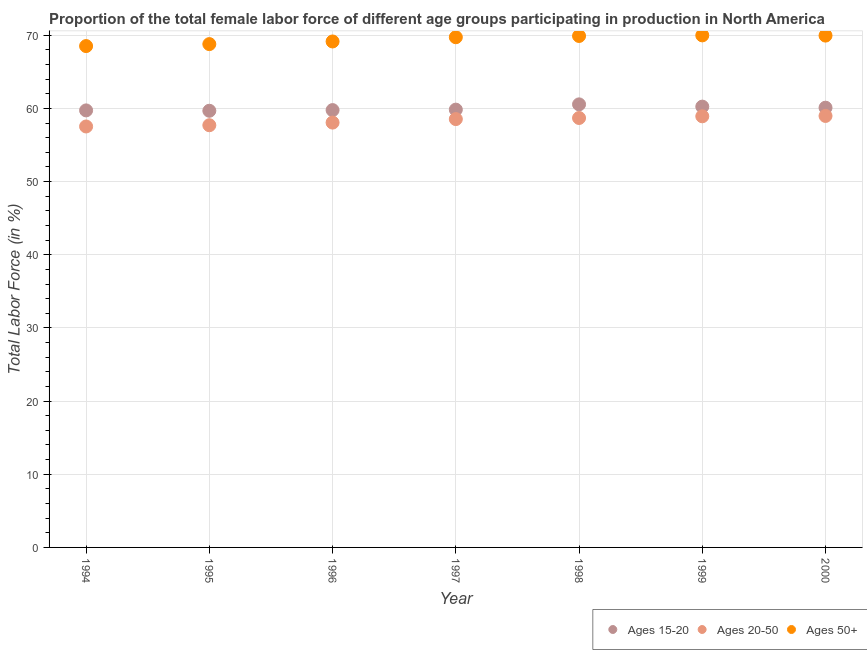How many different coloured dotlines are there?
Give a very brief answer. 3. What is the percentage of female labor force above age 50 in 1994?
Your answer should be compact. 68.52. Across all years, what is the maximum percentage of female labor force within the age group 15-20?
Make the answer very short. 60.55. Across all years, what is the minimum percentage of female labor force above age 50?
Offer a very short reply. 68.52. What is the total percentage of female labor force within the age group 20-50 in the graph?
Keep it short and to the point. 408.41. What is the difference between the percentage of female labor force above age 50 in 1995 and that in 1996?
Your answer should be compact. -0.36. What is the difference between the percentage of female labor force within the age group 20-50 in 1997 and the percentage of female labor force above age 50 in 1996?
Keep it short and to the point. -10.61. What is the average percentage of female labor force within the age group 15-20 per year?
Offer a very short reply. 59.99. In the year 1996, what is the difference between the percentage of female labor force above age 50 and percentage of female labor force within the age group 15-20?
Provide a short and direct response. 9.38. In how many years, is the percentage of female labor force within the age group 20-50 greater than 54 %?
Give a very brief answer. 7. What is the ratio of the percentage of female labor force within the age group 20-50 in 1998 to that in 1999?
Your response must be concise. 1. What is the difference between the highest and the second highest percentage of female labor force within the age group 15-20?
Make the answer very short. 0.31. What is the difference between the highest and the lowest percentage of female labor force above age 50?
Give a very brief answer. 1.46. Is the sum of the percentage of female labor force within the age group 15-20 in 1995 and 1997 greater than the maximum percentage of female labor force within the age group 20-50 across all years?
Provide a succinct answer. Yes. How many years are there in the graph?
Offer a terse response. 7. Are the values on the major ticks of Y-axis written in scientific E-notation?
Provide a short and direct response. No. Does the graph contain grids?
Offer a terse response. Yes. Where does the legend appear in the graph?
Keep it short and to the point. Bottom right. How are the legend labels stacked?
Provide a succinct answer. Horizontal. What is the title of the graph?
Provide a succinct answer. Proportion of the total female labor force of different age groups participating in production in North America. What is the label or title of the Y-axis?
Ensure brevity in your answer.  Total Labor Force (in %). What is the Total Labor Force (in %) of Ages 15-20 in 1994?
Provide a succinct answer. 59.73. What is the Total Labor Force (in %) of Ages 20-50 in 1994?
Keep it short and to the point. 57.53. What is the Total Labor Force (in %) in Ages 50+ in 1994?
Offer a very short reply. 68.52. What is the Total Labor Force (in %) in Ages 15-20 in 1995?
Provide a short and direct response. 59.68. What is the Total Labor Force (in %) of Ages 20-50 in 1995?
Offer a terse response. 57.7. What is the Total Labor Force (in %) of Ages 50+ in 1995?
Your response must be concise. 68.79. What is the Total Labor Force (in %) of Ages 15-20 in 1996?
Provide a succinct answer. 59.77. What is the Total Labor Force (in %) in Ages 20-50 in 1996?
Your answer should be compact. 58.06. What is the Total Labor Force (in %) in Ages 50+ in 1996?
Your answer should be very brief. 69.15. What is the Total Labor Force (in %) in Ages 15-20 in 1997?
Offer a very short reply. 59.83. What is the Total Labor Force (in %) of Ages 20-50 in 1997?
Your answer should be compact. 58.54. What is the Total Labor Force (in %) of Ages 50+ in 1997?
Your answer should be compact. 69.73. What is the Total Labor Force (in %) in Ages 15-20 in 1998?
Keep it short and to the point. 60.55. What is the Total Labor Force (in %) in Ages 20-50 in 1998?
Provide a succinct answer. 58.69. What is the Total Labor Force (in %) of Ages 50+ in 1998?
Make the answer very short. 69.9. What is the Total Labor Force (in %) in Ages 15-20 in 1999?
Provide a succinct answer. 60.24. What is the Total Labor Force (in %) of Ages 20-50 in 1999?
Make the answer very short. 58.92. What is the Total Labor Force (in %) in Ages 50+ in 1999?
Offer a terse response. 69.98. What is the Total Labor Force (in %) of Ages 15-20 in 2000?
Offer a very short reply. 60.1. What is the Total Labor Force (in %) of Ages 20-50 in 2000?
Your answer should be very brief. 58.97. What is the Total Labor Force (in %) in Ages 50+ in 2000?
Give a very brief answer. 69.95. Across all years, what is the maximum Total Labor Force (in %) in Ages 15-20?
Give a very brief answer. 60.55. Across all years, what is the maximum Total Labor Force (in %) of Ages 20-50?
Ensure brevity in your answer.  58.97. Across all years, what is the maximum Total Labor Force (in %) in Ages 50+?
Provide a succinct answer. 69.98. Across all years, what is the minimum Total Labor Force (in %) of Ages 15-20?
Ensure brevity in your answer.  59.68. Across all years, what is the minimum Total Labor Force (in %) of Ages 20-50?
Provide a short and direct response. 57.53. Across all years, what is the minimum Total Labor Force (in %) in Ages 50+?
Keep it short and to the point. 68.52. What is the total Total Labor Force (in %) in Ages 15-20 in the graph?
Provide a short and direct response. 419.9. What is the total Total Labor Force (in %) in Ages 20-50 in the graph?
Offer a very short reply. 408.41. What is the total Total Labor Force (in %) in Ages 50+ in the graph?
Offer a very short reply. 486.01. What is the difference between the Total Labor Force (in %) in Ages 15-20 in 1994 and that in 1995?
Keep it short and to the point. 0.05. What is the difference between the Total Labor Force (in %) in Ages 20-50 in 1994 and that in 1995?
Your answer should be compact. -0.17. What is the difference between the Total Labor Force (in %) of Ages 50+ in 1994 and that in 1995?
Provide a succinct answer. -0.27. What is the difference between the Total Labor Force (in %) in Ages 15-20 in 1994 and that in 1996?
Your answer should be very brief. -0.04. What is the difference between the Total Labor Force (in %) of Ages 20-50 in 1994 and that in 1996?
Your answer should be very brief. -0.53. What is the difference between the Total Labor Force (in %) of Ages 50+ in 1994 and that in 1996?
Your answer should be compact. -0.63. What is the difference between the Total Labor Force (in %) of Ages 15-20 in 1994 and that in 1997?
Make the answer very short. -0.11. What is the difference between the Total Labor Force (in %) in Ages 20-50 in 1994 and that in 1997?
Provide a short and direct response. -1.01. What is the difference between the Total Labor Force (in %) of Ages 50+ in 1994 and that in 1997?
Give a very brief answer. -1.21. What is the difference between the Total Labor Force (in %) in Ages 15-20 in 1994 and that in 1998?
Your answer should be very brief. -0.82. What is the difference between the Total Labor Force (in %) of Ages 20-50 in 1994 and that in 1998?
Give a very brief answer. -1.16. What is the difference between the Total Labor Force (in %) of Ages 50+ in 1994 and that in 1998?
Your answer should be very brief. -1.38. What is the difference between the Total Labor Force (in %) of Ages 15-20 in 1994 and that in 1999?
Offer a very short reply. -0.52. What is the difference between the Total Labor Force (in %) in Ages 20-50 in 1994 and that in 1999?
Provide a short and direct response. -1.39. What is the difference between the Total Labor Force (in %) of Ages 50+ in 1994 and that in 1999?
Keep it short and to the point. -1.46. What is the difference between the Total Labor Force (in %) of Ages 15-20 in 1994 and that in 2000?
Offer a terse response. -0.37. What is the difference between the Total Labor Force (in %) of Ages 20-50 in 1994 and that in 2000?
Offer a terse response. -1.44. What is the difference between the Total Labor Force (in %) in Ages 50+ in 1994 and that in 2000?
Keep it short and to the point. -1.43. What is the difference between the Total Labor Force (in %) of Ages 15-20 in 1995 and that in 1996?
Make the answer very short. -0.09. What is the difference between the Total Labor Force (in %) in Ages 20-50 in 1995 and that in 1996?
Give a very brief answer. -0.36. What is the difference between the Total Labor Force (in %) of Ages 50+ in 1995 and that in 1996?
Provide a succinct answer. -0.36. What is the difference between the Total Labor Force (in %) in Ages 15-20 in 1995 and that in 1997?
Offer a terse response. -0.16. What is the difference between the Total Labor Force (in %) of Ages 20-50 in 1995 and that in 1997?
Your answer should be very brief. -0.84. What is the difference between the Total Labor Force (in %) of Ages 50+ in 1995 and that in 1997?
Keep it short and to the point. -0.94. What is the difference between the Total Labor Force (in %) of Ages 15-20 in 1995 and that in 1998?
Ensure brevity in your answer.  -0.88. What is the difference between the Total Labor Force (in %) of Ages 20-50 in 1995 and that in 1998?
Provide a short and direct response. -0.99. What is the difference between the Total Labor Force (in %) in Ages 50+ in 1995 and that in 1998?
Offer a very short reply. -1.11. What is the difference between the Total Labor Force (in %) of Ages 15-20 in 1995 and that in 1999?
Your answer should be very brief. -0.57. What is the difference between the Total Labor Force (in %) in Ages 20-50 in 1995 and that in 1999?
Your answer should be compact. -1.22. What is the difference between the Total Labor Force (in %) in Ages 50+ in 1995 and that in 1999?
Provide a succinct answer. -1.19. What is the difference between the Total Labor Force (in %) of Ages 15-20 in 1995 and that in 2000?
Keep it short and to the point. -0.42. What is the difference between the Total Labor Force (in %) of Ages 20-50 in 1995 and that in 2000?
Offer a terse response. -1.27. What is the difference between the Total Labor Force (in %) in Ages 50+ in 1995 and that in 2000?
Offer a very short reply. -1.16. What is the difference between the Total Labor Force (in %) of Ages 15-20 in 1996 and that in 1997?
Provide a succinct answer. -0.06. What is the difference between the Total Labor Force (in %) of Ages 20-50 in 1996 and that in 1997?
Your answer should be compact. -0.48. What is the difference between the Total Labor Force (in %) in Ages 50+ in 1996 and that in 1997?
Provide a succinct answer. -0.58. What is the difference between the Total Labor Force (in %) in Ages 15-20 in 1996 and that in 1998?
Provide a succinct answer. -0.78. What is the difference between the Total Labor Force (in %) of Ages 20-50 in 1996 and that in 1998?
Your answer should be compact. -0.63. What is the difference between the Total Labor Force (in %) in Ages 50+ in 1996 and that in 1998?
Give a very brief answer. -0.75. What is the difference between the Total Labor Force (in %) of Ages 15-20 in 1996 and that in 1999?
Your answer should be compact. -0.48. What is the difference between the Total Labor Force (in %) in Ages 20-50 in 1996 and that in 1999?
Offer a very short reply. -0.86. What is the difference between the Total Labor Force (in %) of Ages 50+ in 1996 and that in 1999?
Provide a short and direct response. -0.83. What is the difference between the Total Labor Force (in %) of Ages 15-20 in 1996 and that in 2000?
Offer a very short reply. -0.33. What is the difference between the Total Labor Force (in %) of Ages 20-50 in 1996 and that in 2000?
Provide a succinct answer. -0.91. What is the difference between the Total Labor Force (in %) of Ages 50+ in 1996 and that in 2000?
Ensure brevity in your answer.  -0.8. What is the difference between the Total Labor Force (in %) in Ages 15-20 in 1997 and that in 1998?
Provide a succinct answer. -0.72. What is the difference between the Total Labor Force (in %) of Ages 20-50 in 1997 and that in 1998?
Give a very brief answer. -0.15. What is the difference between the Total Labor Force (in %) of Ages 50+ in 1997 and that in 1998?
Your answer should be very brief. -0.17. What is the difference between the Total Labor Force (in %) in Ages 15-20 in 1997 and that in 1999?
Ensure brevity in your answer.  -0.41. What is the difference between the Total Labor Force (in %) in Ages 20-50 in 1997 and that in 1999?
Provide a short and direct response. -0.38. What is the difference between the Total Labor Force (in %) in Ages 50+ in 1997 and that in 1999?
Provide a short and direct response. -0.25. What is the difference between the Total Labor Force (in %) in Ages 15-20 in 1997 and that in 2000?
Keep it short and to the point. -0.26. What is the difference between the Total Labor Force (in %) of Ages 20-50 in 1997 and that in 2000?
Ensure brevity in your answer.  -0.43. What is the difference between the Total Labor Force (in %) in Ages 50+ in 1997 and that in 2000?
Your answer should be compact. -0.22. What is the difference between the Total Labor Force (in %) in Ages 15-20 in 1998 and that in 1999?
Give a very brief answer. 0.31. What is the difference between the Total Labor Force (in %) of Ages 20-50 in 1998 and that in 1999?
Offer a terse response. -0.23. What is the difference between the Total Labor Force (in %) in Ages 50+ in 1998 and that in 1999?
Ensure brevity in your answer.  -0.08. What is the difference between the Total Labor Force (in %) of Ages 15-20 in 1998 and that in 2000?
Your response must be concise. 0.45. What is the difference between the Total Labor Force (in %) in Ages 20-50 in 1998 and that in 2000?
Give a very brief answer. -0.28. What is the difference between the Total Labor Force (in %) of Ages 50+ in 1998 and that in 2000?
Make the answer very short. -0.05. What is the difference between the Total Labor Force (in %) in Ages 15-20 in 1999 and that in 2000?
Ensure brevity in your answer.  0.15. What is the difference between the Total Labor Force (in %) of Ages 20-50 in 1999 and that in 2000?
Make the answer very short. -0.05. What is the difference between the Total Labor Force (in %) of Ages 50+ in 1999 and that in 2000?
Make the answer very short. 0.03. What is the difference between the Total Labor Force (in %) of Ages 15-20 in 1994 and the Total Labor Force (in %) of Ages 20-50 in 1995?
Provide a short and direct response. 2.03. What is the difference between the Total Labor Force (in %) in Ages 15-20 in 1994 and the Total Labor Force (in %) in Ages 50+ in 1995?
Your response must be concise. -9.06. What is the difference between the Total Labor Force (in %) of Ages 20-50 in 1994 and the Total Labor Force (in %) of Ages 50+ in 1995?
Your answer should be compact. -11.26. What is the difference between the Total Labor Force (in %) in Ages 15-20 in 1994 and the Total Labor Force (in %) in Ages 20-50 in 1996?
Your answer should be very brief. 1.67. What is the difference between the Total Labor Force (in %) of Ages 15-20 in 1994 and the Total Labor Force (in %) of Ages 50+ in 1996?
Provide a succinct answer. -9.42. What is the difference between the Total Labor Force (in %) in Ages 20-50 in 1994 and the Total Labor Force (in %) in Ages 50+ in 1996?
Your answer should be very brief. -11.62. What is the difference between the Total Labor Force (in %) in Ages 15-20 in 1994 and the Total Labor Force (in %) in Ages 20-50 in 1997?
Give a very brief answer. 1.19. What is the difference between the Total Labor Force (in %) in Ages 15-20 in 1994 and the Total Labor Force (in %) in Ages 50+ in 1997?
Give a very brief answer. -10. What is the difference between the Total Labor Force (in %) of Ages 20-50 in 1994 and the Total Labor Force (in %) of Ages 50+ in 1997?
Your answer should be compact. -12.2. What is the difference between the Total Labor Force (in %) of Ages 15-20 in 1994 and the Total Labor Force (in %) of Ages 20-50 in 1998?
Your response must be concise. 1.04. What is the difference between the Total Labor Force (in %) of Ages 15-20 in 1994 and the Total Labor Force (in %) of Ages 50+ in 1998?
Give a very brief answer. -10.17. What is the difference between the Total Labor Force (in %) of Ages 20-50 in 1994 and the Total Labor Force (in %) of Ages 50+ in 1998?
Your answer should be very brief. -12.37. What is the difference between the Total Labor Force (in %) in Ages 15-20 in 1994 and the Total Labor Force (in %) in Ages 20-50 in 1999?
Your answer should be very brief. 0.81. What is the difference between the Total Labor Force (in %) of Ages 15-20 in 1994 and the Total Labor Force (in %) of Ages 50+ in 1999?
Offer a very short reply. -10.25. What is the difference between the Total Labor Force (in %) in Ages 20-50 in 1994 and the Total Labor Force (in %) in Ages 50+ in 1999?
Make the answer very short. -12.45. What is the difference between the Total Labor Force (in %) in Ages 15-20 in 1994 and the Total Labor Force (in %) in Ages 20-50 in 2000?
Give a very brief answer. 0.76. What is the difference between the Total Labor Force (in %) of Ages 15-20 in 1994 and the Total Labor Force (in %) of Ages 50+ in 2000?
Your answer should be very brief. -10.22. What is the difference between the Total Labor Force (in %) of Ages 20-50 in 1994 and the Total Labor Force (in %) of Ages 50+ in 2000?
Provide a short and direct response. -12.42. What is the difference between the Total Labor Force (in %) of Ages 15-20 in 1995 and the Total Labor Force (in %) of Ages 20-50 in 1996?
Offer a very short reply. 1.62. What is the difference between the Total Labor Force (in %) in Ages 15-20 in 1995 and the Total Labor Force (in %) in Ages 50+ in 1996?
Ensure brevity in your answer.  -9.47. What is the difference between the Total Labor Force (in %) of Ages 20-50 in 1995 and the Total Labor Force (in %) of Ages 50+ in 1996?
Your answer should be compact. -11.45. What is the difference between the Total Labor Force (in %) of Ages 15-20 in 1995 and the Total Labor Force (in %) of Ages 20-50 in 1997?
Give a very brief answer. 1.14. What is the difference between the Total Labor Force (in %) of Ages 15-20 in 1995 and the Total Labor Force (in %) of Ages 50+ in 1997?
Ensure brevity in your answer.  -10.05. What is the difference between the Total Labor Force (in %) of Ages 20-50 in 1995 and the Total Labor Force (in %) of Ages 50+ in 1997?
Offer a terse response. -12.03. What is the difference between the Total Labor Force (in %) of Ages 15-20 in 1995 and the Total Labor Force (in %) of Ages 50+ in 1998?
Give a very brief answer. -10.22. What is the difference between the Total Labor Force (in %) in Ages 20-50 in 1995 and the Total Labor Force (in %) in Ages 50+ in 1998?
Your response must be concise. -12.2. What is the difference between the Total Labor Force (in %) of Ages 15-20 in 1995 and the Total Labor Force (in %) of Ages 20-50 in 1999?
Offer a very short reply. 0.76. What is the difference between the Total Labor Force (in %) in Ages 15-20 in 1995 and the Total Labor Force (in %) in Ages 50+ in 1999?
Your answer should be compact. -10.3. What is the difference between the Total Labor Force (in %) in Ages 20-50 in 1995 and the Total Labor Force (in %) in Ages 50+ in 1999?
Make the answer very short. -12.28. What is the difference between the Total Labor Force (in %) in Ages 15-20 in 1995 and the Total Labor Force (in %) in Ages 20-50 in 2000?
Offer a very short reply. 0.71. What is the difference between the Total Labor Force (in %) in Ages 15-20 in 1995 and the Total Labor Force (in %) in Ages 50+ in 2000?
Your answer should be compact. -10.27. What is the difference between the Total Labor Force (in %) in Ages 20-50 in 1995 and the Total Labor Force (in %) in Ages 50+ in 2000?
Offer a very short reply. -12.25. What is the difference between the Total Labor Force (in %) of Ages 15-20 in 1996 and the Total Labor Force (in %) of Ages 20-50 in 1997?
Your answer should be very brief. 1.23. What is the difference between the Total Labor Force (in %) of Ages 15-20 in 1996 and the Total Labor Force (in %) of Ages 50+ in 1997?
Give a very brief answer. -9.96. What is the difference between the Total Labor Force (in %) of Ages 20-50 in 1996 and the Total Labor Force (in %) of Ages 50+ in 1997?
Ensure brevity in your answer.  -11.67. What is the difference between the Total Labor Force (in %) in Ages 15-20 in 1996 and the Total Labor Force (in %) in Ages 20-50 in 1998?
Your response must be concise. 1.08. What is the difference between the Total Labor Force (in %) in Ages 15-20 in 1996 and the Total Labor Force (in %) in Ages 50+ in 1998?
Offer a very short reply. -10.13. What is the difference between the Total Labor Force (in %) in Ages 20-50 in 1996 and the Total Labor Force (in %) in Ages 50+ in 1998?
Keep it short and to the point. -11.84. What is the difference between the Total Labor Force (in %) in Ages 15-20 in 1996 and the Total Labor Force (in %) in Ages 20-50 in 1999?
Provide a succinct answer. 0.85. What is the difference between the Total Labor Force (in %) in Ages 15-20 in 1996 and the Total Labor Force (in %) in Ages 50+ in 1999?
Offer a terse response. -10.21. What is the difference between the Total Labor Force (in %) in Ages 20-50 in 1996 and the Total Labor Force (in %) in Ages 50+ in 1999?
Ensure brevity in your answer.  -11.92. What is the difference between the Total Labor Force (in %) in Ages 15-20 in 1996 and the Total Labor Force (in %) in Ages 20-50 in 2000?
Ensure brevity in your answer.  0.8. What is the difference between the Total Labor Force (in %) in Ages 15-20 in 1996 and the Total Labor Force (in %) in Ages 50+ in 2000?
Offer a very short reply. -10.18. What is the difference between the Total Labor Force (in %) in Ages 20-50 in 1996 and the Total Labor Force (in %) in Ages 50+ in 2000?
Ensure brevity in your answer.  -11.89. What is the difference between the Total Labor Force (in %) of Ages 15-20 in 1997 and the Total Labor Force (in %) of Ages 20-50 in 1998?
Your answer should be very brief. 1.14. What is the difference between the Total Labor Force (in %) in Ages 15-20 in 1997 and the Total Labor Force (in %) in Ages 50+ in 1998?
Your answer should be very brief. -10.07. What is the difference between the Total Labor Force (in %) in Ages 20-50 in 1997 and the Total Labor Force (in %) in Ages 50+ in 1998?
Make the answer very short. -11.36. What is the difference between the Total Labor Force (in %) of Ages 15-20 in 1997 and the Total Labor Force (in %) of Ages 20-50 in 1999?
Offer a very short reply. 0.91. What is the difference between the Total Labor Force (in %) of Ages 15-20 in 1997 and the Total Labor Force (in %) of Ages 50+ in 1999?
Keep it short and to the point. -10.15. What is the difference between the Total Labor Force (in %) of Ages 20-50 in 1997 and the Total Labor Force (in %) of Ages 50+ in 1999?
Your answer should be very brief. -11.44. What is the difference between the Total Labor Force (in %) of Ages 15-20 in 1997 and the Total Labor Force (in %) of Ages 20-50 in 2000?
Your answer should be very brief. 0.86. What is the difference between the Total Labor Force (in %) in Ages 15-20 in 1997 and the Total Labor Force (in %) in Ages 50+ in 2000?
Make the answer very short. -10.12. What is the difference between the Total Labor Force (in %) in Ages 20-50 in 1997 and the Total Labor Force (in %) in Ages 50+ in 2000?
Your answer should be very brief. -11.41. What is the difference between the Total Labor Force (in %) of Ages 15-20 in 1998 and the Total Labor Force (in %) of Ages 20-50 in 1999?
Provide a short and direct response. 1.63. What is the difference between the Total Labor Force (in %) of Ages 15-20 in 1998 and the Total Labor Force (in %) of Ages 50+ in 1999?
Ensure brevity in your answer.  -9.43. What is the difference between the Total Labor Force (in %) in Ages 20-50 in 1998 and the Total Labor Force (in %) in Ages 50+ in 1999?
Offer a very short reply. -11.29. What is the difference between the Total Labor Force (in %) in Ages 15-20 in 1998 and the Total Labor Force (in %) in Ages 20-50 in 2000?
Your answer should be very brief. 1.58. What is the difference between the Total Labor Force (in %) of Ages 15-20 in 1998 and the Total Labor Force (in %) of Ages 50+ in 2000?
Ensure brevity in your answer.  -9.4. What is the difference between the Total Labor Force (in %) of Ages 20-50 in 1998 and the Total Labor Force (in %) of Ages 50+ in 2000?
Keep it short and to the point. -11.26. What is the difference between the Total Labor Force (in %) in Ages 15-20 in 1999 and the Total Labor Force (in %) in Ages 20-50 in 2000?
Your answer should be compact. 1.27. What is the difference between the Total Labor Force (in %) in Ages 15-20 in 1999 and the Total Labor Force (in %) in Ages 50+ in 2000?
Provide a short and direct response. -9.71. What is the difference between the Total Labor Force (in %) in Ages 20-50 in 1999 and the Total Labor Force (in %) in Ages 50+ in 2000?
Your answer should be compact. -11.03. What is the average Total Labor Force (in %) of Ages 15-20 per year?
Your answer should be very brief. 59.99. What is the average Total Labor Force (in %) in Ages 20-50 per year?
Keep it short and to the point. 58.34. What is the average Total Labor Force (in %) of Ages 50+ per year?
Ensure brevity in your answer.  69.43. In the year 1994, what is the difference between the Total Labor Force (in %) in Ages 15-20 and Total Labor Force (in %) in Ages 20-50?
Your answer should be compact. 2.2. In the year 1994, what is the difference between the Total Labor Force (in %) in Ages 15-20 and Total Labor Force (in %) in Ages 50+?
Make the answer very short. -8.79. In the year 1994, what is the difference between the Total Labor Force (in %) in Ages 20-50 and Total Labor Force (in %) in Ages 50+?
Give a very brief answer. -10.99. In the year 1995, what is the difference between the Total Labor Force (in %) of Ages 15-20 and Total Labor Force (in %) of Ages 20-50?
Make the answer very short. 1.98. In the year 1995, what is the difference between the Total Labor Force (in %) of Ages 15-20 and Total Labor Force (in %) of Ages 50+?
Your answer should be very brief. -9.11. In the year 1995, what is the difference between the Total Labor Force (in %) in Ages 20-50 and Total Labor Force (in %) in Ages 50+?
Offer a very short reply. -11.09. In the year 1996, what is the difference between the Total Labor Force (in %) of Ages 15-20 and Total Labor Force (in %) of Ages 20-50?
Your response must be concise. 1.71. In the year 1996, what is the difference between the Total Labor Force (in %) in Ages 15-20 and Total Labor Force (in %) in Ages 50+?
Provide a short and direct response. -9.38. In the year 1996, what is the difference between the Total Labor Force (in %) in Ages 20-50 and Total Labor Force (in %) in Ages 50+?
Make the answer very short. -11.09. In the year 1997, what is the difference between the Total Labor Force (in %) in Ages 15-20 and Total Labor Force (in %) in Ages 20-50?
Your response must be concise. 1.29. In the year 1997, what is the difference between the Total Labor Force (in %) in Ages 15-20 and Total Labor Force (in %) in Ages 50+?
Provide a short and direct response. -9.9. In the year 1997, what is the difference between the Total Labor Force (in %) in Ages 20-50 and Total Labor Force (in %) in Ages 50+?
Your response must be concise. -11.19. In the year 1998, what is the difference between the Total Labor Force (in %) in Ages 15-20 and Total Labor Force (in %) in Ages 20-50?
Your answer should be compact. 1.86. In the year 1998, what is the difference between the Total Labor Force (in %) in Ages 15-20 and Total Labor Force (in %) in Ages 50+?
Provide a short and direct response. -9.35. In the year 1998, what is the difference between the Total Labor Force (in %) of Ages 20-50 and Total Labor Force (in %) of Ages 50+?
Make the answer very short. -11.21. In the year 1999, what is the difference between the Total Labor Force (in %) of Ages 15-20 and Total Labor Force (in %) of Ages 20-50?
Your answer should be compact. 1.32. In the year 1999, what is the difference between the Total Labor Force (in %) in Ages 15-20 and Total Labor Force (in %) in Ages 50+?
Offer a terse response. -9.74. In the year 1999, what is the difference between the Total Labor Force (in %) of Ages 20-50 and Total Labor Force (in %) of Ages 50+?
Provide a short and direct response. -11.06. In the year 2000, what is the difference between the Total Labor Force (in %) of Ages 15-20 and Total Labor Force (in %) of Ages 20-50?
Offer a very short reply. 1.13. In the year 2000, what is the difference between the Total Labor Force (in %) in Ages 15-20 and Total Labor Force (in %) in Ages 50+?
Your response must be concise. -9.85. In the year 2000, what is the difference between the Total Labor Force (in %) in Ages 20-50 and Total Labor Force (in %) in Ages 50+?
Your answer should be compact. -10.98. What is the ratio of the Total Labor Force (in %) in Ages 15-20 in 1994 to that in 1995?
Offer a terse response. 1. What is the ratio of the Total Labor Force (in %) of Ages 20-50 in 1994 to that in 1995?
Make the answer very short. 1. What is the ratio of the Total Labor Force (in %) of Ages 20-50 in 1994 to that in 1996?
Your answer should be very brief. 0.99. What is the ratio of the Total Labor Force (in %) in Ages 50+ in 1994 to that in 1996?
Your response must be concise. 0.99. What is the ratio of the Total Labor Force (in %) of Ages 15-20 in 1994 to that in 1997?
Ensure brevity in your answer.  1. What is the ratio of the Total Labor Force (in %) of Ages 20-50 in 1994 to that in 1997?
Your answer should be very brief. 0.98. What is the ratio of the Total Labor Force (in %) of Ages 50+ in 1994 to that in 1997?
Your answer should be very brief. 0.98. What is the ratio of the Total Labor Force (in %) of Ages 15-20 in 1994 to that in 1998?
Keep it short and to the point. 0.99. What is the ratio of the Total Labor Force (in %) of Ages 20-50 in 1994 to that in 1998?
Keep it short and to the point. 0.98. What is the ratio of the Total Labor Force (in %) of Ages 50+ in 1994 to that in 1998?
Your answer should be very brief. 0.98. What is the ratio of the Total Labor Force (in %) in Ages 15-20 in 1994 to that in 1999?
Make the answer very short. 0.99. What is the ratio of the Total Labor Force (in %) in Ages 20-50 in 1994 to that in 1999?
Provide a succinct answer. 0.98. What is the ratio of the Total Labor Force (in %) of Ages 50+ in 1994 to that in 1999?
Your response must be concise. 0.98. What is the ratio of the Total Labor Force (in %) of Ages 15-20 in 1994 to that in 2000?
Your response must be concise. 0.99. What is the ratio of the Total Labor Force (in %) of Ages 20-50 in 1994 to that in 2000?
Offer a terse response. 0.98. What is the ratio of the Total Labor Force (in %) in Ages 50+ in 1994 to that in 2000?
Your answer should be very brief. 0.98. What is the ratio of the Total Labor Force (in %) in Ages 50+ in 1995 to that in 1996?
Provide a short and direct response. 0.99. What is the ratio of the Total Labor Force (in %) in Ages 15-20 in 1995 to that in 1997?
Your response must be concise. 1. What is the ratio of the Total Labor Force (in %) of Ages 20-50 in 1995 to that in 1997?
Ensure brevity in your answer.  0.99. What is the ratio of the Total Labor Force (in %) in Ages 50+ in 1995 to that in 1997?
Provide a short and direct response. 0.99. What is the ratio of the Total Labor Force (in %) of Ages 15-20 in 1995 to that in 1998?
Offer a very short reply. 0.99. What is the ratio of the Total Labor Force (in %) in Ages 20-50 in 1995 to that in 1998?
Make the answer very short. 0.98. What is the ratio of the Total Labor Force (in %) of Ages 50+ in 1995 to that in 1998?
Provide a succinct answer. 0.98. What is the ratio of the Total Labor Force (in %) in Ages 15-20 in 1995 to that in 1999?
Keep it short and to the point. 0.99. What is the ratio of the Total Labor Force (in %) of Ages 20-50 in 1995 to that in 1999?
Offer a terse response. 0.98. What is the ratio of the Total Labor Force (in %) of Ages 20-50 in 1995 to that in 2000?
Give a very brief answer. 0.98. What is the ratio of the Total Labor Force (in %) of Ages 50+ in 1995 to that in 2000?
Keep it short and to the point. 0.98. What is the ratio of the Total Labor Force (in %) in Ages 15-20 in 1996 to that in 1997?
Offer a terse response. 1. What is the ratio of the Total Labor Force (in %) in Ages 50+ in 1996 to that in 1997?
Offer a terse response. 0.99. What is the ratio of the Total Labor Force (in %) of Ages 15-20 in 1996 to that in 1998?
Make the answer very short. 0.99. What is the ratio of the Total Labor Force (in %) in Ages 20-50 in 1996 to that in 1998?
Give a very brief answer. 0.99. What is the ratio of the Total Labor Force (in %) of Ages 50+ in 1996 to that in 1998?
Your answer should be compact. 0.99. What is the ratio of the Total Labor Force (in %) in Ages 15-20 in 1996 to that in 1999?
Your answer should be very brief. 0.99. What is the ratio of the Total Labor Force (in %) in Ages 20-50 in 1996 to that in 1999?
Your answer should be very brief. 0.99. What is the ratio of the Total Labor Force (in %) in Ages 50+ in 1996 to that in 1999?
Provide a short and direct response. 0.99. What is the ratio of the Total Labor Force (in %) in Ages 15-20 in 1996 to that in 2000?
Your response must be concise. 0.99. What is the ratio of the Total Labor Force (in %) in Ages 20-50 in 1996 to that in 2000?
Provide a succinct answer. 0.98. What is the ratio of the Total Labor Force (in %) of Ages 20-50 in 1997 to that in 1998?
Provide a short and direct response. 1. What is the ratio of the Total Labor Force (in %) in Ages 50+ in 1997 to that in 1998?
Ensure brevity in your answer.  1. What is the ratio of the Total Labor Force (in %) of Ages 20-50 in 1997 to that in 1999?
Your answer should be very brief. 0.99. What is the ratio of the Total Labor Force (in %) in Ages 50+ in 1997 to that in 1999?
Offer a very short reply. 1. What is the ratio of the Total Labor Force (in %) of Ages 20-50 in 1997 to that in 2000?
Your answer should be very brief. 0.99. What is the ratio of the Total Labor Force (in %) of Ages 50+ in 1997 to that in 2000?
Make the answer very short. 1. What is the ratio of the Total Labor Force (in %) in Ages 15-20 in 1998 to that in 1999?
Provide a short and direct response. 1.01. What is the ratio of the Total Labor Force (in %) of Ages 20-50 in 1998 to that in 1999?
Make the answer very short. 1. What is the ratio of the Total Labor Force (in %) in Ages 15-20 in 1998 to that in 2000?
Your response must be concise. 1.01. What is the ratio of the Total Labor Force (in %) in Ages 20-50 in 1998 to that in 2000?
Your response must be concise. 1. What is the ratio of the Total Labor Force (in %) in Ages 20-50 in 1999 to that in 2000?
Provide a succinct answer. 1. What is the ratio of the Total Labor Force (in %) of Ages 50+ in 1999 to that in 2000?
Make the answer very short. 1. What is the difference between the highest and the second highest Total Labor Force (in %) in Ages 15-20?
Offer a terse response. 0.31. What is the difference between the highest and the second highest Total Labor Force (in %) of Ages 20-50?
Your answer should be very brief. 0.05. What is the difference between the highest and the second highest Total Labor Force (in %) in Ages 50+?
Give a very brief answer. 0.03. What is the difference between the highest and the lowest Total Labor Force (in %) in Ages 15-20?
Your answer should be very brief. 0.88. What is the difference between the highest and the lowest Total Labor Force (in %) of Ages 20-50?
Provide a succinct answer. 1.44. What is the difference between the highest and the lowest Total Labor Force (in %) in Ages 50+?
Offer a very short reply. 1.46. 